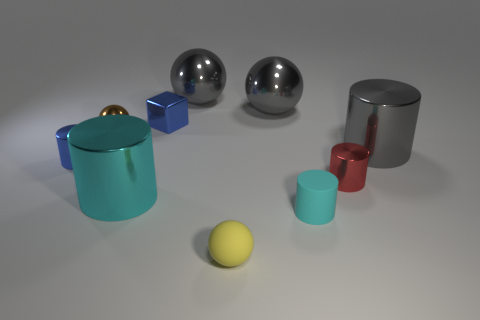There is a blue block that is the same size as the brown metal thing; what material is it? metal 